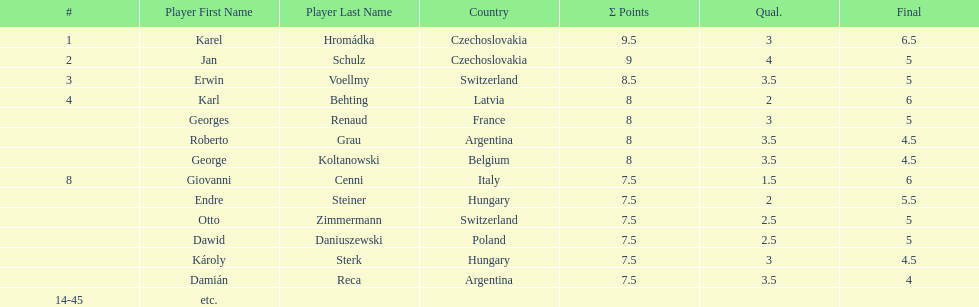Who was the top scorer from switzerland? Erwin Voellmy. 